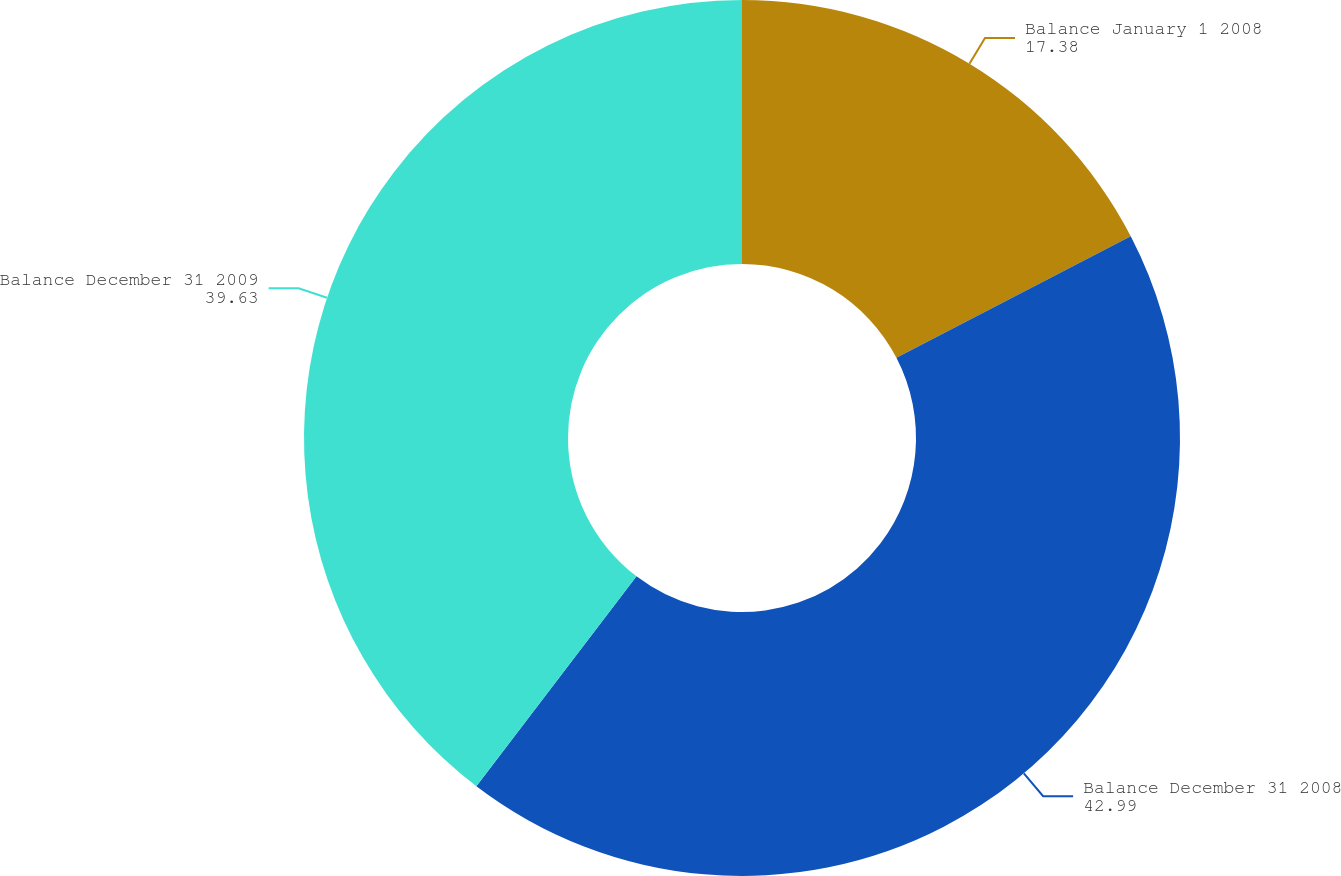Convert chart to OTSL. <chart><loc_0><loc_0><loc_500><loc_500><pie_chart><fcel>Balance January 1 2008<fcel>Balance December 31 2008<fcel>Balance December 31 2009<nl><fcel>17.38%<fcel>42.99%<fcel>39.63%<nl></chart> 